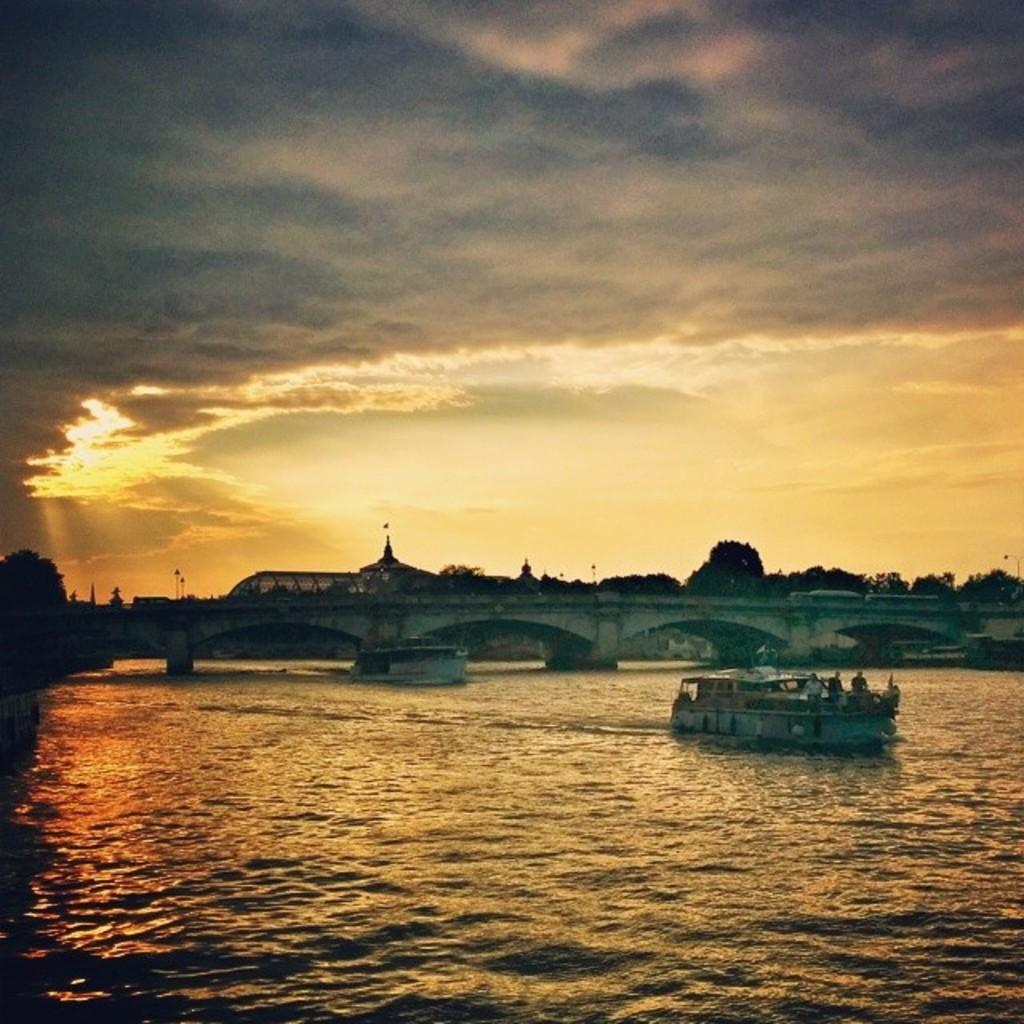What type of water body is present in the image? There is a river in the image. What is on the river in the image? There are boats on the river. What can be seen in the background of the image? There is a bridge and trees in the background of the image. What is visible in the sky in the image? The sky is visible in the background of the image. How does the river attack the boats in the image? The river does not attack the boats in the image; it is a natural water body that flows peacefully. 